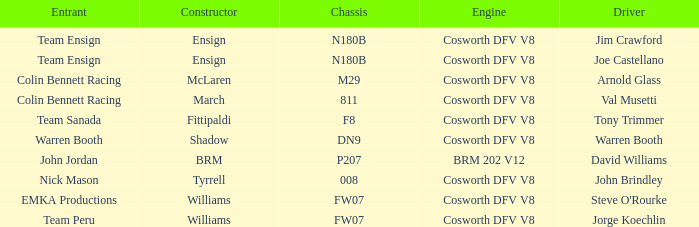Who built Warren Booth's car with the Cosworth DFV V8 engine? Shadow. 